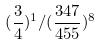Convert formula to latex. <formula><loc_0><loc_0><loc_500><loc_500>( \frac { 3 } { 4 } ) ^ { 1 } / ( \frac { 3 4 7 } { 4 5 5 } ) ^ { 8 }</formula> 